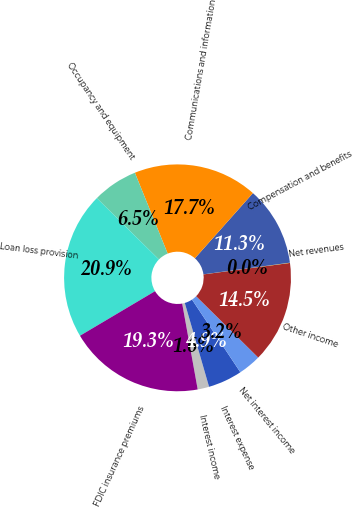Convert chart to OTSL. <chart><loc_0><loc_0><loc_500><loc_500><pie_chart><fcel>Interest income<fcel>Interest expense<fcel>Net interest income<fcel>Other income<fcel>Net revenues<fcel>Compensation and benefits<fcel>Communications and information<fcel>Occupancy and equipment<fcel>Loan loss provision<fcel>FDIC insurance premiums<nl><fcel>1.64%<fcel>4.86%<fcel>3.25%<fcel>14.5%<fcel>0.04%<fcel>11.29%<fcel>17.71%<fcel>6.46%<fcel>20.93%<fcel>19.32%<nl></chart> 